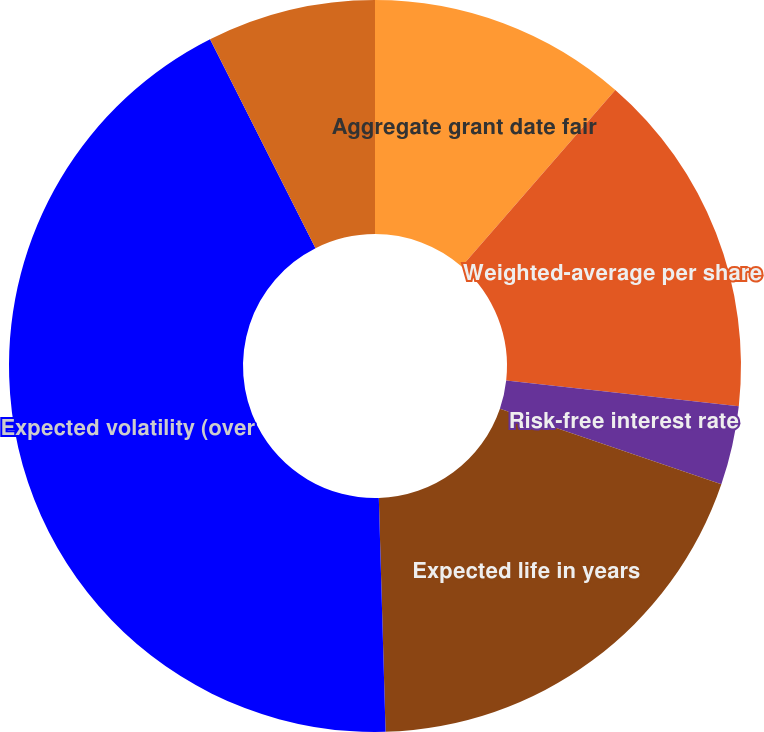Convert chart to OTSL. <chart><loc_0><loc_0><loc_500><loc_500><pie_chart><fcel>Aggregate grant date fair<fcel>Weighted-average per share<fcel>Risk-free interest rate<fcel>Expected life in years<fcel>Expected volatility (over<fcel>Expected dividend yield (over<nl><fcel>11.4%<fcel>15.35%<fcel>3.49%<fcel>19.3%<fcel>43.02%<fcel>7.44%<nl></chart> 